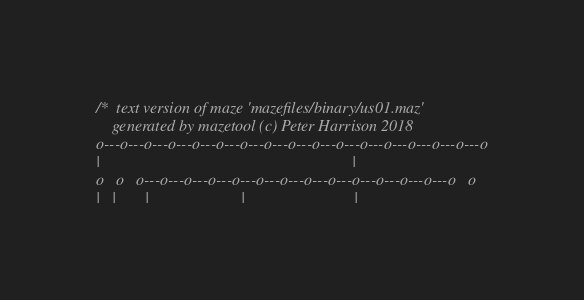Convert code to text. <code><loc_0><loc_0><loc_500><loc_500><_C_>
/*  text version of maze 'mazefiles/binary/us01.maz' 
    generated by mazetool (c) Peter Harrison 2018 
o---o---o---o---o---o---o---o---o---o---o---o---o---o---o---o---o
|                                                               |
o   o   o---o---o---o---o---o---o---o---o---o---o---o---o---o   o
|   |       |                       |                           |</code> 